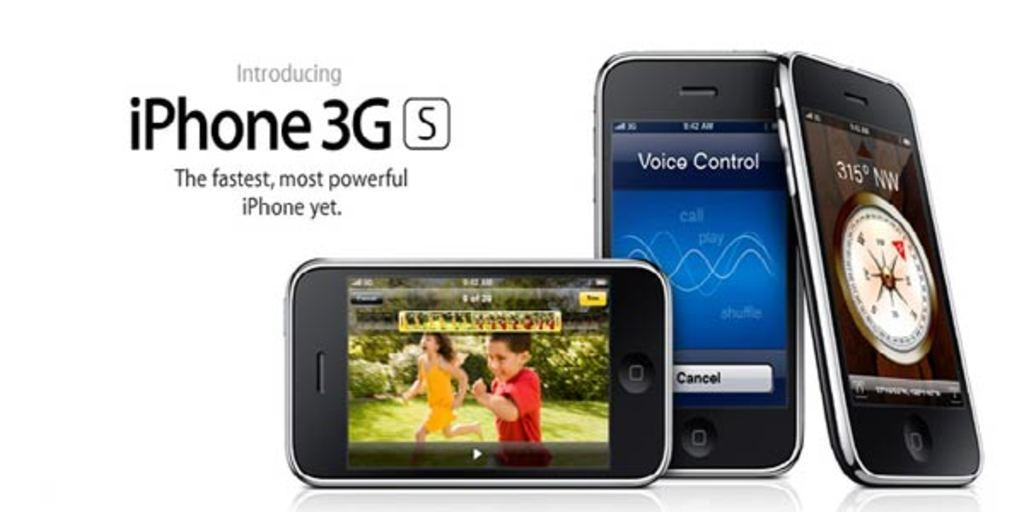<image>
Give a short and clear explanation of the subsequent image. A row of iPhones are on a white background and the ad says Introducing iPhone 3G S. 